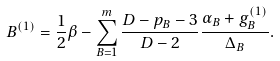Convert formula to latex. <formula><loc_0><loc_0><loc_500><loc_500>B ^ { ( 1 ) } = \frac { 1 } { 2 } \beta - \sum _ { B = 1 } ^ { m } \frac { D - p _ { B } - 3 } { D - 2 } \frac { \alpha _ { B } + g _ { B } ^ { ( 1 ) } } { \Delta _ { B } } .</formula> 